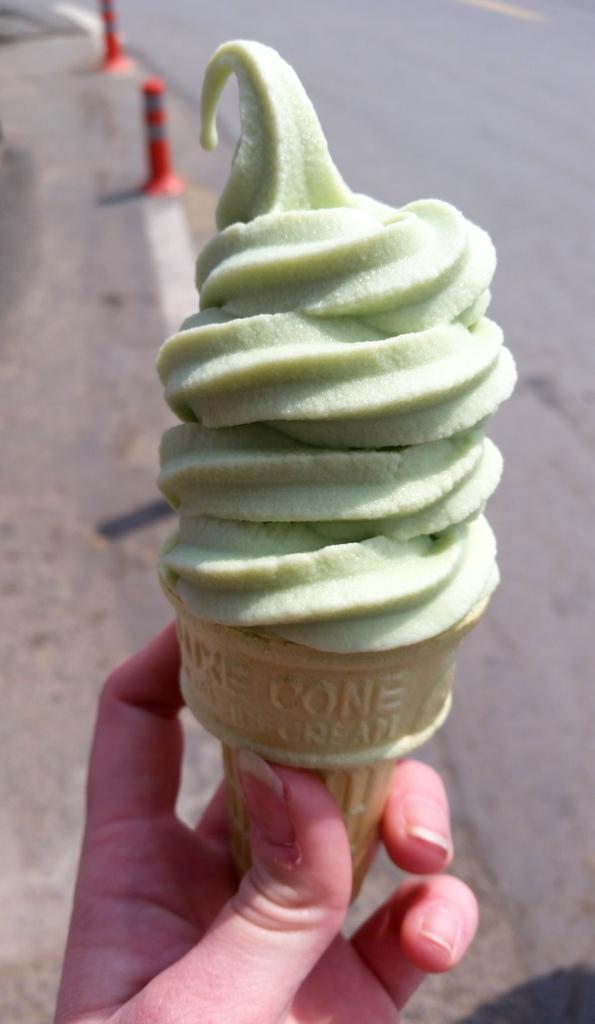Please provide a concise description of this image. In this image in the foreground there is one person who is holding an ice cream, and in the background there is a road and two barricades. 